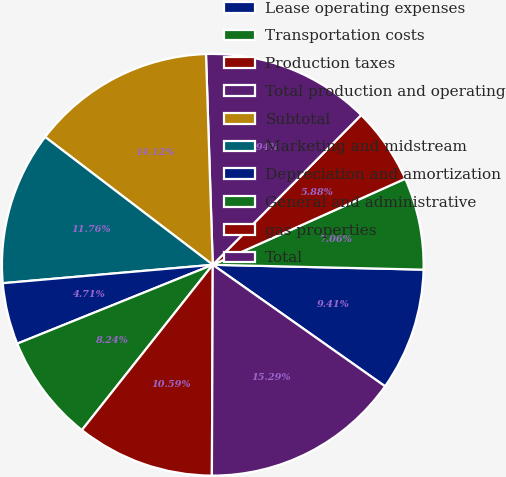Convert chart. <chart><loc_0><loc_0><loc_500><loc_500><pie_chart><fcel>Lease operating expenses<fcel>Transportation costs<fcel>Production taxes<fcel>Total production and operating<fcel>Subtotal<fcel>Marketing and midstream<fcel>Depreciation and amortization<fcel>General and administrative<fcel>gas properties<fcel>Total<nl><fcel>9.41%<fcel>7.06%<fcel>5.88%<fcel>12.94%<fcel>14.12%<fcel>11.76%<fcel>4.71%<fcel>8.24%<fcel>10.59%<fcel>15.29%<nl></chart> 